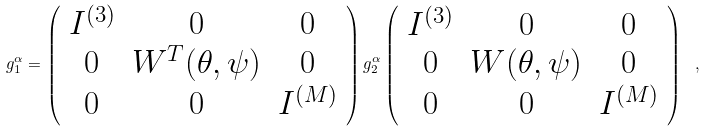<formula> <loc_0><loc_0><loc_500><loc_500>g _ { 1 } ^ { \alpha } = \left ( \begin{array} { c c c } I ^ { ( 3 ) } & 0 & 0 \\ 0 & W ^ { T } ( \theta , \psi ) & 0 \\ 0 & 0 & I ^ { ( M ) } \end{array} \right ) g _ { 2 } ^ { \alpha } \left ( \begin{array} { c c c } I ^ { ( 3 ) } & 0 & 0 \\ 0 & W ( \theta , \psi ) & 0 \\ 0 & 0 & I ^ { ( M ) } \end{array} \right ) \ ,</formula> 